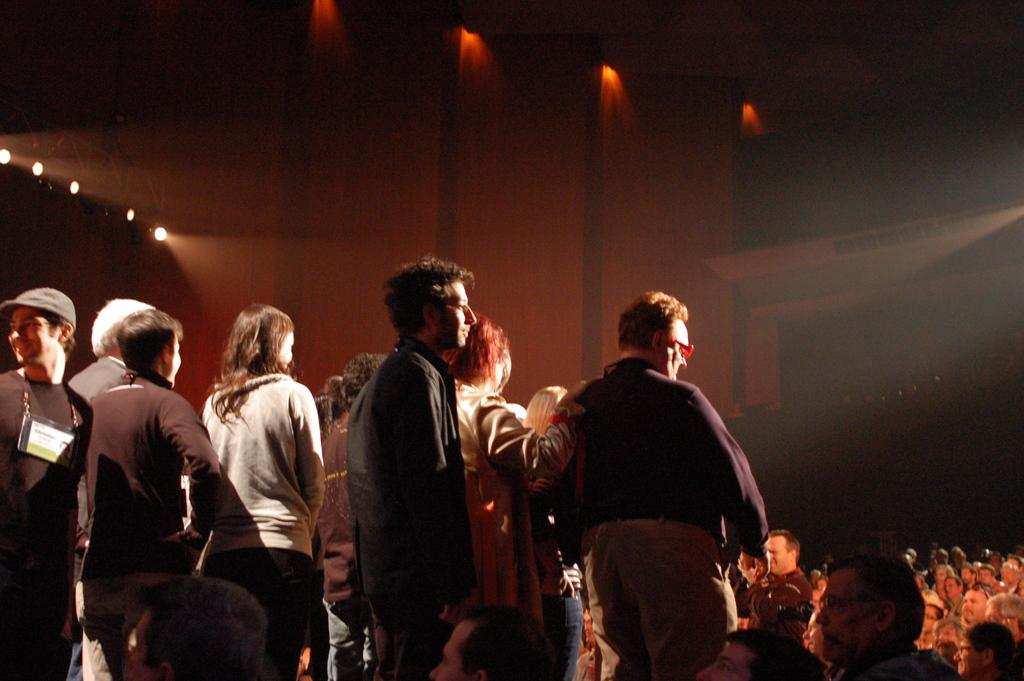How many people are in the image? There is a group of people in the image. Can you describe the clothing of the person in the front? The person in the front is wearing a maroon shirt and cream-colored pants. What can be seen in the background of the image? There are other people and lights visible in the background of the image. What type of tax is being discussed by the group of people in the image? There is no indication in the image that the group of people is discussing any type of tax. 